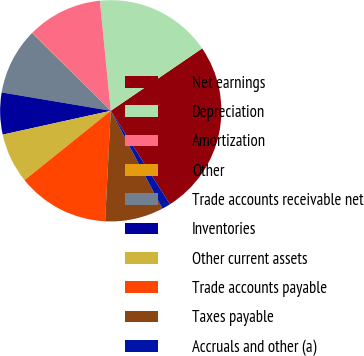Convert chart. <chart><loc_0><loc_0><loc_500><loc_500><pie_chart><fcel>Net earnings<fcel>Depreciation<fcel>Amortization<fcel>Other<fcel>Trade accounts receivable net<fcel>Inventories<fcel>Other current assets<fcel>Trade accounts payable<fcel>Taxes payable<fcel>Accruals and other (a)<nl><fcel>25.54%<fcel>17.04%<fcel>10.97%<fcel>0.04%<fcel>9.76%<fcel>6.11%<fcel>7.33%<fcel>13.4%<fcel>8.54%<fcel>1.26%<nl></chart> 